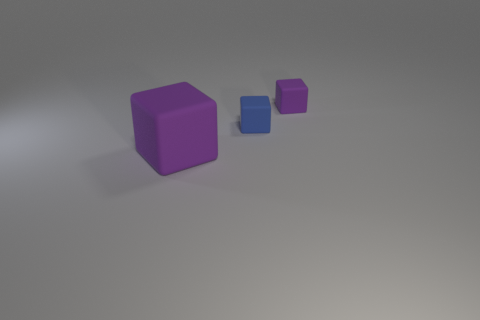What number of purple cubes are to the left of the blue thing and on the right side of the big block?
Your answer should be compact. 0. How many purple objects are behind the purple matte block that is to the left of the purple block that is behind the large purple block?
Your response must be concise. 1. What is the size of the object that is the same color as the large cube?
Offer a terse response. Small. There is a large matte thing; what shape is it?
Provide a succinct answer. Cube. How many blue things have the same material as the large purple thing?
Keep it short and to the point. 1. The tiny cube that is the same material as the small purple object is what color?
Your response must be concise. Blue. Do the blue object and the purple object that is behind the large matte block have the same size?
Your answer should be very brief. Yes. What material is the purple thing that is in front of the purple cube behind the rubber thing that is in front of the blue rubber cube?
Give a very brief answer. Rubber. How many things are tiny matte things or blue rubber objects?
Your response must be concise. 2. There is a matte object that is on the left side of the small blue rubber block; does it have the same color as the tiny rubber cube that is right of the blue thing?
Your answer should be compact. Yes. 